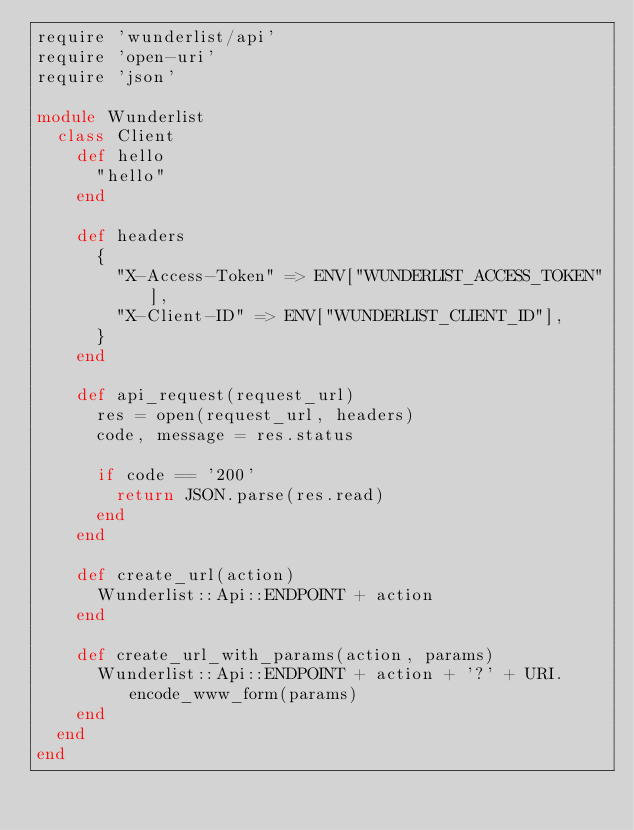Convert code to text. <code><loc_0><loc_0><loc_500><loc_500><_Ruby_>require 'wunderlist/api'
require 'open-uri'
require 'json'

module Wunderlist
  class Client
    def hello
      "hello"
    end

    def headers
      {
        "X-Access-Token" => ENV["WUNDERLIST_ACCESS_TOKEN"],
        "X-Client-ID" => ENV["WUNDERLIST_CLIENT_ID"],
      }
    end

    def api_request(request_url)
      res = open(request_url, headers)
      code, message = res.status

      if code == '200'
        return JSON.parse(res.read)
      end
    end

    def create_url(action)
      Wunderlist::Api::ENDPOINT + action
    end

    def create_url_with_params(action, params)
      Wunderlist::Api::ENDPOINT + action + '?' + URI.encode_www_form(params)
    end
  end
end
</code> 